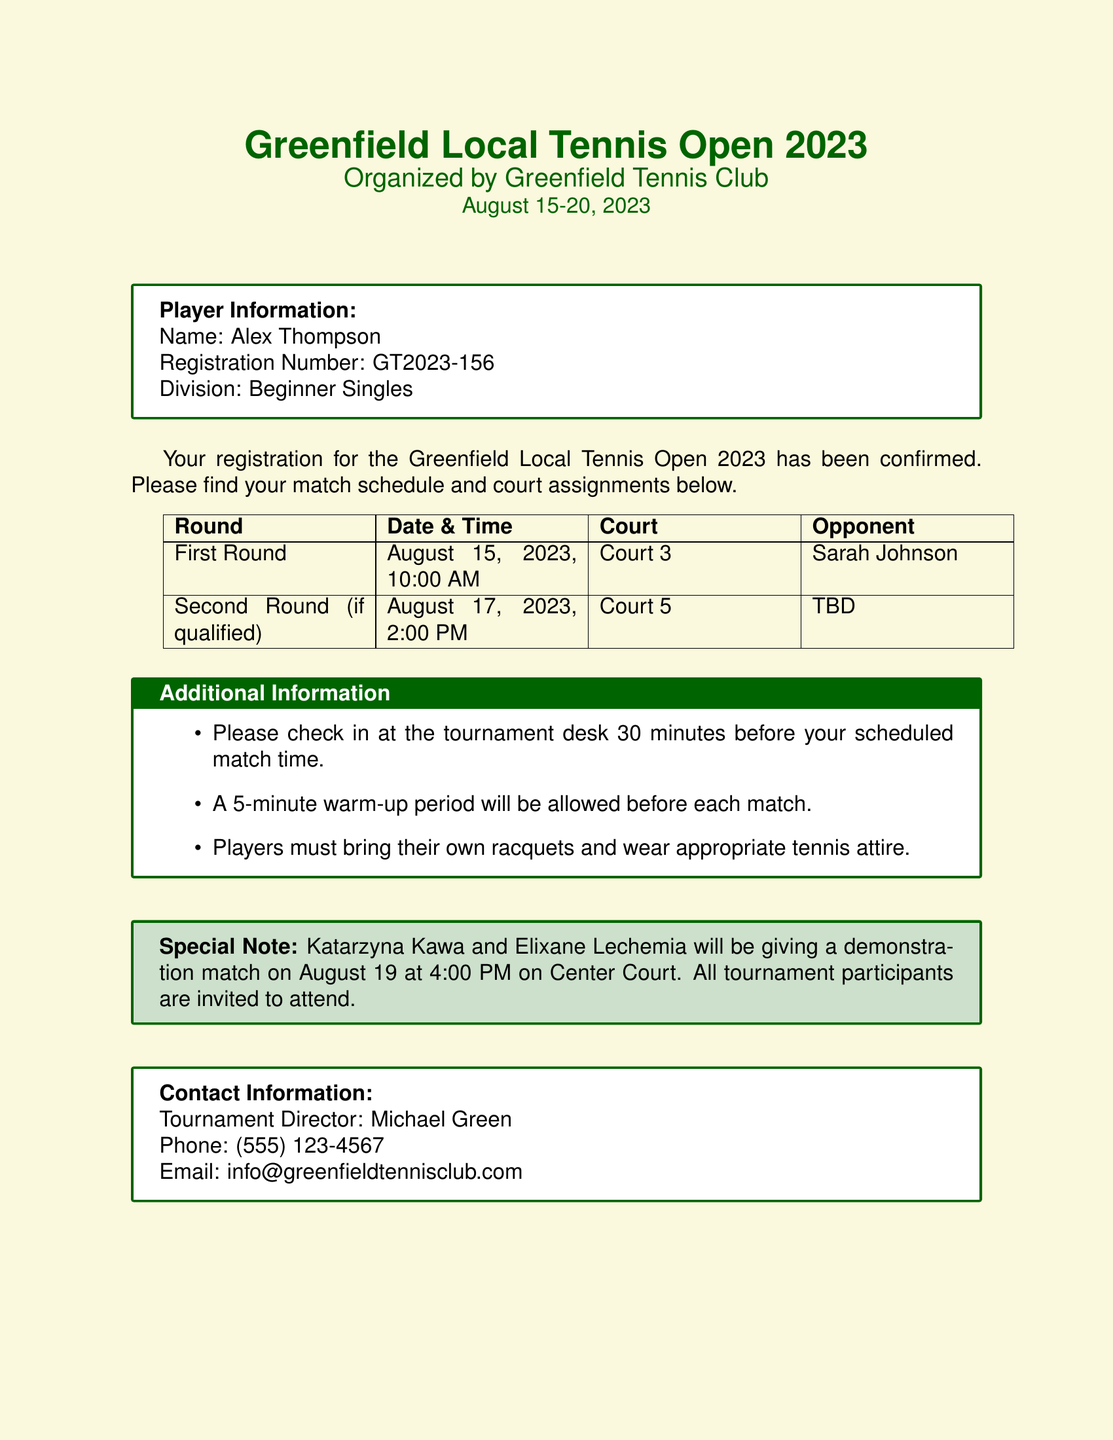What is the tournament name? The tournament name is featured prominently at the beginning of the document.
Answer: Greenfield Local Tennis Open 2023 Who is the tournament director? The director's contact information is provided in the last section.
Answer: Michael Green On which court will the first match be played? The court assignment for the first round is explicitly stated in the match schedule.
Answer: Court 3 What is the opponent's name in the first round? The opponent's name for the first round is listed in the match schedule.
Answer: Sarah Johnson When is the demonstration match featuring Katarzyna Kawa and Elixane Lechemia? The date and time for the special match are mentioned in the additional information section.
Answer: August 19 at 4:00 PM What should players bring to the tournament? The additional information specifies what players need to have during the tournament.
Answer: Their own racquets If qualified, on what date will the second round be held? The date for the second round is indicated in the match schedule, contingent on qualification.
Answer: August 17, 2023 How long is the warm-up period allowed before matches? The duration for the warm-up period is mentioned in the additional information section.
Answer: 5 minutes What is the registration number of Alex Thompson? The player information section lists the registration number for Alex Thompson.
Answer: GT2023-156 